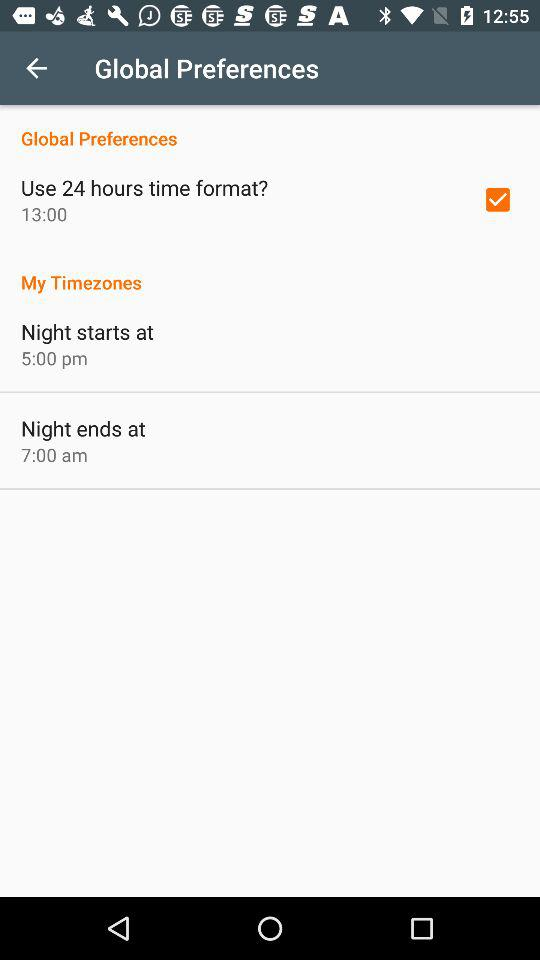What is the status of "Use 24 hours time format"? The status is "on". 